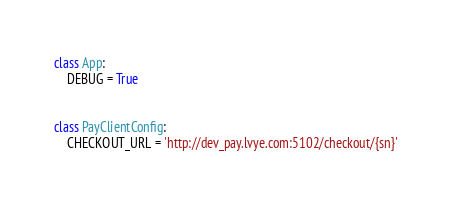<code> <loc_0><loc_0><loc_500><loc_500><_Python_>

class App:
    DEBUG = True


class PayClientConfig:
    CHECKOUT_URL = 'http://dev_pay.lvye.com:5102/checkout/{sn}'
</code> 